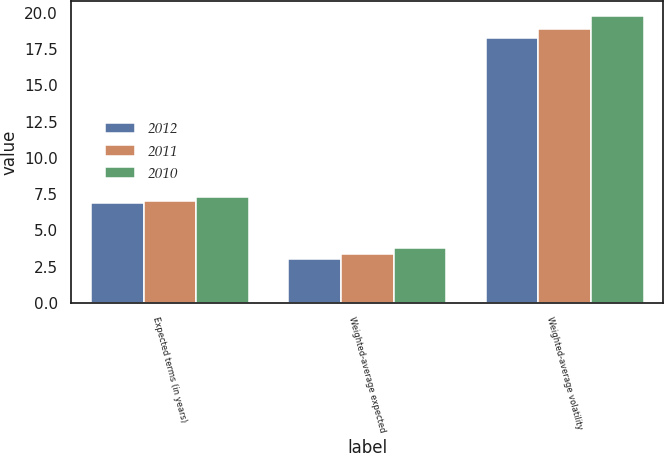<chart> <loc_0><loc_0><loc_500><loc_500><stacked_bar_chart><ecel><fcel>Expected terms (in years)<fcel>Weighted-average expected<fcel>Weighted-average volatility<nl><fcel>2012<fcel>6.9<fcel>3<fcel>18.3<nl><fcel>2011<fcel>7<fcel>3.4<fcel>18.9<nl><fcel>2010<fcel>7.3<fcel>3.8<fcel>19.8<nl></chart> 